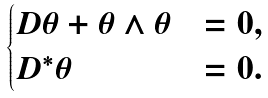Convert formula to latex. <formula><loc_0><loc_0><loc_500><loc_500>\begin{cases} D \theta + \theta \wedge \theta & = 0 , \\ D ^ { * } \theta & = 0 . \end{cases}</formula> 